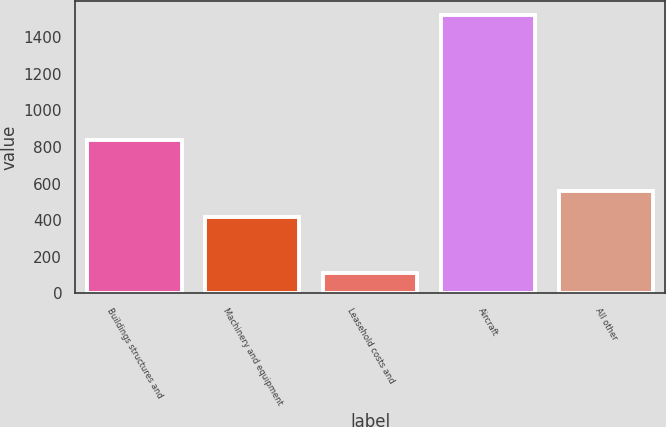<chart> <loc_0><loc_0><loc_500><loc_500><bar_chart><fcel>Buildings structures and<fcel>Machinery and equipment<fcel>Leasehold costs and<fcel>Aircraft<fcel>All other<nl><fcel>840<fcel>420<fcel>110<fcel>1520<fcel>561<nl></chart> 